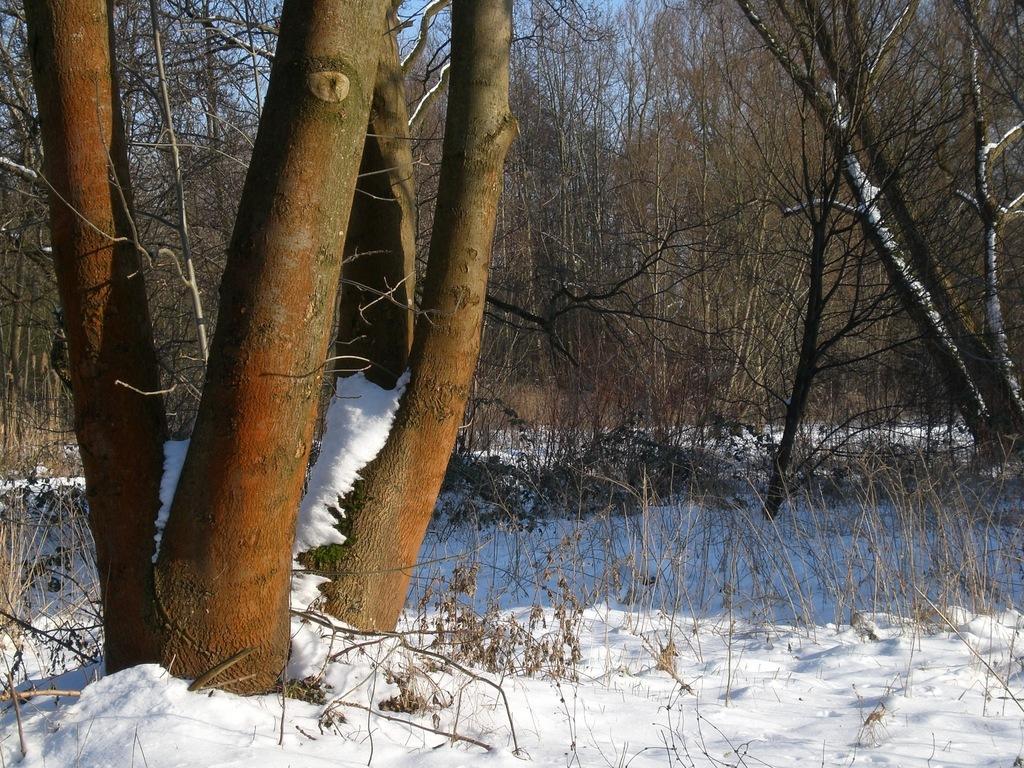Describe this image in one or two sentences. In this image I can see few dry trees and the snow. I can see the sky. 